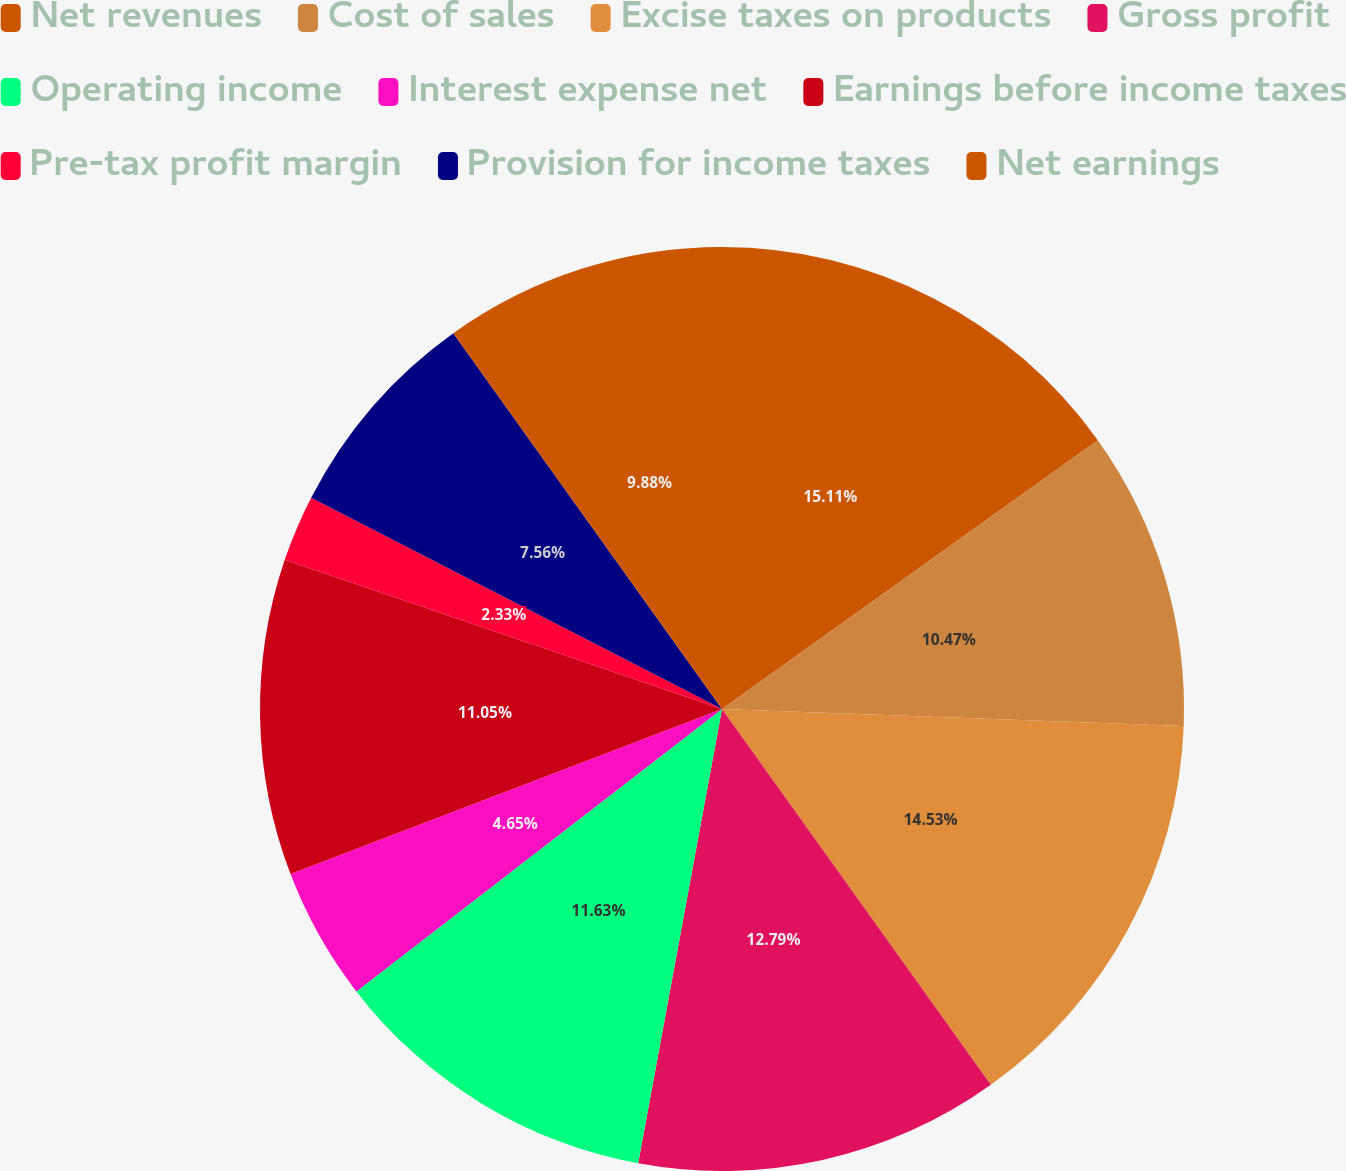Convert chart to OTSL. <chart><loc_0><loc_0><loc_500><loc_500><pie_chart><fcel>Net revenues<fcel>Cost of sales<fcel>Excise taxes on products<fcel>Gross profit<fcel>Operating income<fcel>Interest expense net<fcel>Earnings before income taxes<fcel>Pre-tax profit margin<fcel>Provision for income taxes<fcel>Net earnings<nl><fcel>15.12%<fcel>10.47%<fcel>14.53%<fcel>12.79%<fcel>11.63%<fcel>4.65%<fcel>11.05%<fcel>2.33%<fcel>7.56%<fcel>9.88%<nl></chart> 